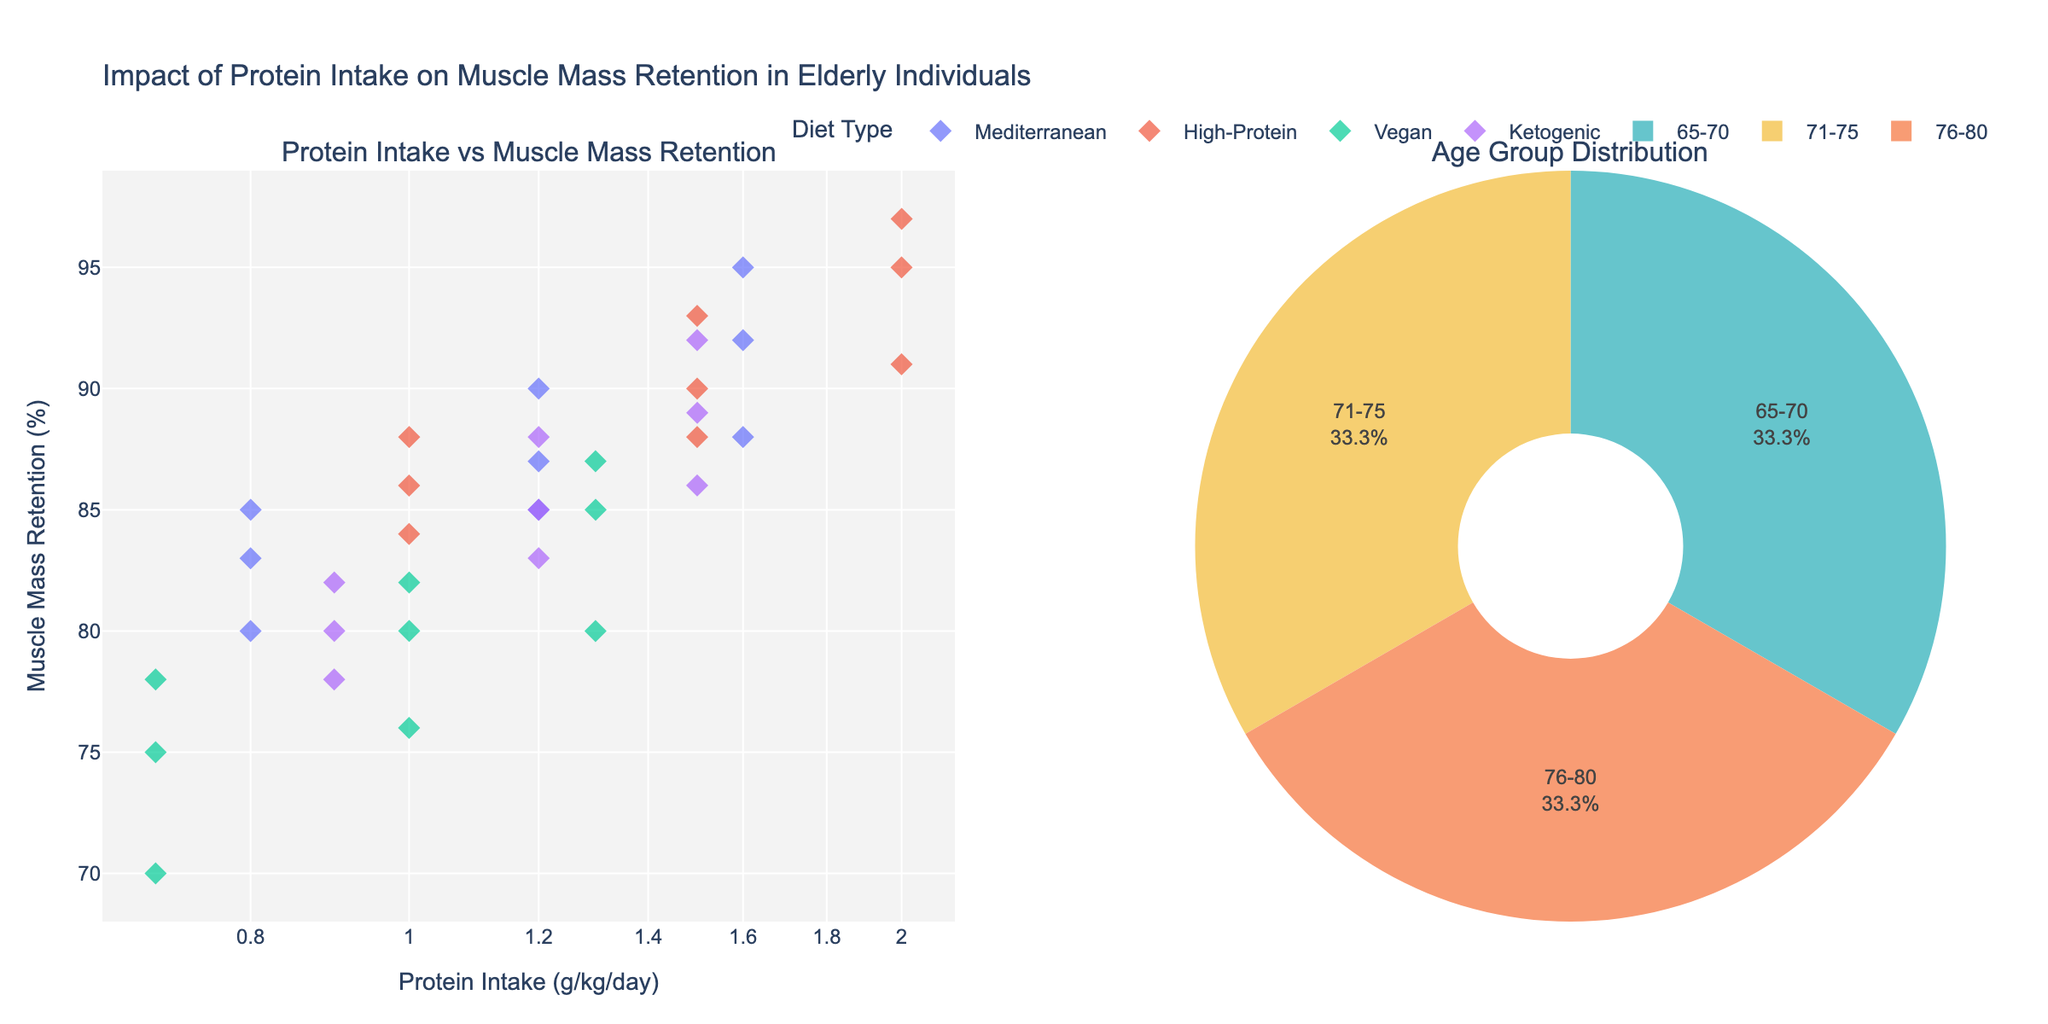How many age groups are represented in the pie chart? The pie chart shows slices labeled for different age groups. Counting these distinct labels will provide the number of age groups.
Answer: 3 Which diet type has the highest muscle mass retention at the lowest protein intake level? The scatter plot shows different diets, with each having several data points. Identify the lowest protein intake for each diet, then check for the one with the highest muscle mass retention percentage.
Answer: High-Protein What is the relationship between protein intake and muscle mass retention across different diets for the age group 65-70? Observe the scatter plot and focus on data points labeled for the age group 65-70. Compare the trend between protein intake (x-axis) and muscle mass retention (y-axis) across different diet types.
Answer: Positive correlation Which age group has the highest percentage representation in the pie chart? Examine the pie chart and identify the segment with the largest size. The label on this segment indicates the age group with the highest percentage.
Answer: 65-70 What's the average muscle mass retention for the Vegan diet across all age groups? Identify all data points for the Vegan diet on the scatter plot. Sum their muscle mass retention percentages and divide by the number of data points to get the average. (78+82+87+75+80+85+70+76+80)/9
Answer: 79.222% Is there a diet that consistently shows higher muscle mass retention across all age groups at a similar protein intake level? Compare the trends for each diet across the scatter plot for each age group. Check if a particular diet consistently stays above others at specific protein intake levels.
Answer: High-Protein How does muscle mass retention change with age for a protein intake of around 1.2 g/kg/day in the Mediterranean diet? Find all Mediterranean diet data points around 1.2 g/kg/day and compare muscle mass retention percentages across different age groups.
Answer: Declines with age Which has a greater impact on muscle mass retention: increasing protein intake or the type of diet, for elderly individuals? Compare the trends in muscle mass retention within each diet as protein intake increases and across different diets at similar protein intake levels.
Answer: Protein intake What's the muscle mass retention percentage for the Ketogenic diet at protein intake of 1.5 g/kg/day for the age group 71-75? Locate the Ketogenic diet data point with a protein intake of 1.5 g/kg/day and a label for the age group 71-75 on the scatter plot.
Answer: 89% Do higher protein intakes always lead to higher muscle mass retention regardless of diet and age group? Examine the scatter plot to see if higher protein intakes correspond to higher muscle mass retention percentages across all age groups and diets.
Answer: Generally, yes 